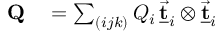<formula> <loc_0><loc_0><loc_500><loc_500>\begin{array} { r l } { Q } & = \sum _ { ( i j k ) } Q _ { i } \, \underline { { \vec { t } } } _ { i } \otimes \underline { { \vec { t } } } _ { i } } \end{array}</formula> 